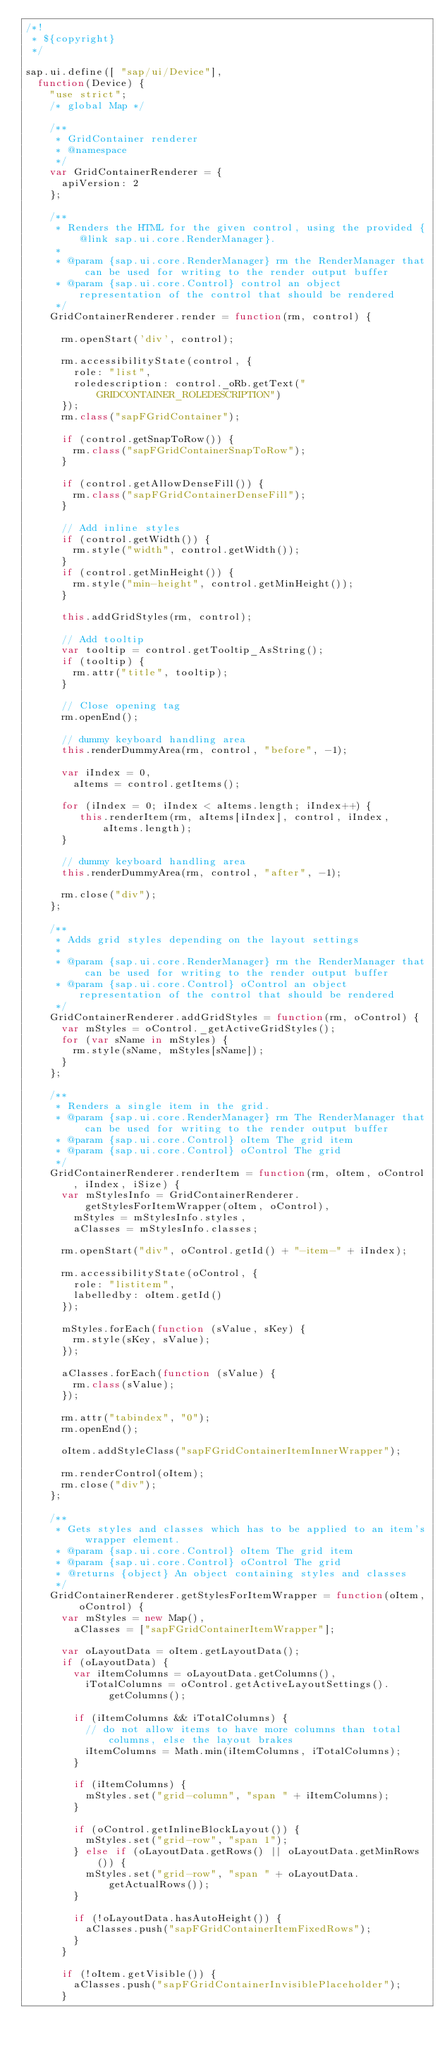<code> <loc_0><loc_0><loc_500><loc_500><_JavaScript_>/*!
 * ${copyright}
 */

sap.ui.define([ "sap/ui/Device"],
	function(Device) {
		"use strict";
		/* global Map */

		/**
		 * GridContainer renderer
		 * @namespace
		 */
		var GridContainerRenderer = {
			apiVersion: 2
		};

		/**
		 * Renders the HTML for the given control, using the provided {@link sap.ui.core.RenderManager}.
		 *
		 * @param {sap.ui.core.RenderManager} rm the RenderManager that can be used for writing to the render output buffer
		 * @param {sap.ui.core.Control} control an object representation of the control that should be rendered
		 */
		GridContainerRenderer.render = function(rm, control) {

			rm.openStart('div', control);

			rm.accessibilityState(control, {
				role: "list",
				roledescription: control._oRb.getText("GRIDCONTAINER_ROLEDESCRIPTION")
			});
			rm.class("sapFGridContainer");

			if (control.getSnapToRow()) {
				rm.class("sapFGridContainerSnapToRow");
			}

			if (control.getAllowDenseFill()) {
				rm.class("sapFGridContainerDenseFill");
			}

			// Add inline styles
			if (control.getWidth()) {
				rm.style("width", control.getWidth());
			}
			if (control.getMinHeight()) {
				rm.style("min-height", control.getMinHeight());
			}

			this.addGridStyles(rm, control);

			// Add tooltip
			var tooltip = control.getTooltip_AsString();
			if (tooltip) {
				rm.attr("title", tooltip);
			}

			// Close opening tag
			rm.openEnd();

			// dummy keyboard handling area
			this.renderDummyArea(rm, control, "before", -1);

			var iIndex = 0,
				aItems = control.getItems();

			for (iIndex = 0; iIndex < aItems.length; iIndex++) {
				 this.renderItem(rm, aItems[iIndex], control, iIndex, aItems.length);
			}

			// dummy keyboard handling area
			this.renderDummyArea(rm, control, "after", -1);

			rm.close("div");
		};

		/**
		 * Adds grid styles depending on the layout settings
		 *
		 * @param {sap.ui.core.RenderManager} rm the RenderManager that can be used for writing to the render output buffer
		 * @param {sap.ui.core.Control} oControl an object representation of the control that should be rendered
		 */
		GridContainerRenderer.addGridStyles = function(rm, oControl) {
			var mStyles = oControl._getActiveGridStyles();
			for (var sName in mStyles) {
				rm.style(sName, mStyles[sName]);
			}
		};

		/**
		 * Renders a single item in the grid.
		 * @param {sap.ui.core.RenderManager} rm The RenderManager that can be used for writing to the render output buffer
		 * @param {sap.ui.core.Control} oItem The grid item
		 * @param {sap.ui.core.Control} oControl The grid
		 */
		GridContainerRenderer.renderItem = function(rm, oItem, oControl, iIndex, iSize) {
			var mStylesInfo = GridContainerRenderer.getStylesForItemWrapper(oItem, oControl),
				mStyles = mStylesInfo.styles,
				aClasses = mStylesInfo.classes;

			rm.openStart("div", oControl.getId() + "-item-" + iIndex);

			rm.accessibilityState(oControl, {
				role: "listitem",
				labelledby: oItem.getId()
			});

			mStyles.forEach(function (sValue, sKey) {
				rm.style(sKey, sValue);
			});

			aClasses.forEach(function (sValue) {
				rm.class(sValue);
			});

			rm.attr("tabindex", "0");
			rm.openEnd();

			oItem.addStyleClass("sapFGridContainerItemInnerWrapper");

			rm.renderControl(oItem);
			rm.close("div");
		};

		/**
		 * Gets styles and classes which has to be applied to an item's wrapper element.
		 * @param {sap.ui.core.Control} oItem The grid item
		 * @param {sap.ui.core.Control} oControl The grid
		 * @returns {object} An object containing styles and classes
		 */
		GridContainerRenderer.getStylesForItemWrapper = function(oItem, oControl) {
			var mStyles = new Map(),
				aClasses = ["sapFGridContainerItemWrapper"];

			var oLayoutData = oItem.getLayoutData();
			if (oLayoutData) {
				var iItemColumns = oLayoutData.getColumns(),
					iTotalColumns = oControl.getActiveLayoutSettings().getColumns();

				if (iItemColumns && iTotalColumns) {
					// do not allow items to have more columns than total columns, else the layout brakes
					iItemColumns = Math.min(iItemColumns, iTotalColumns);
				}

				if (iItemColumns) {
					mStyles.set("grid-column", "span " + iItemColumns);
				}

				if (oControl.getInlineBlockLayout()) {
					mStyles.set("grid-row", "span 1");
				} else if (oLayoutData.getRows() || oLayoutData.getMinRows()) {
					mStyles.set("grid-row", "span " + oLayoutData.getActualRows());
				}

				if (!oLayoutData.hasAutoHeight()) {
					aClasses.push("sapFGridContainerItemFixedRows");
				}
			}

			if (!oItem.getVisible()) {
				aClasses.push("sapFGridContainerInvisiblePlaceholder");
			}
</code> 